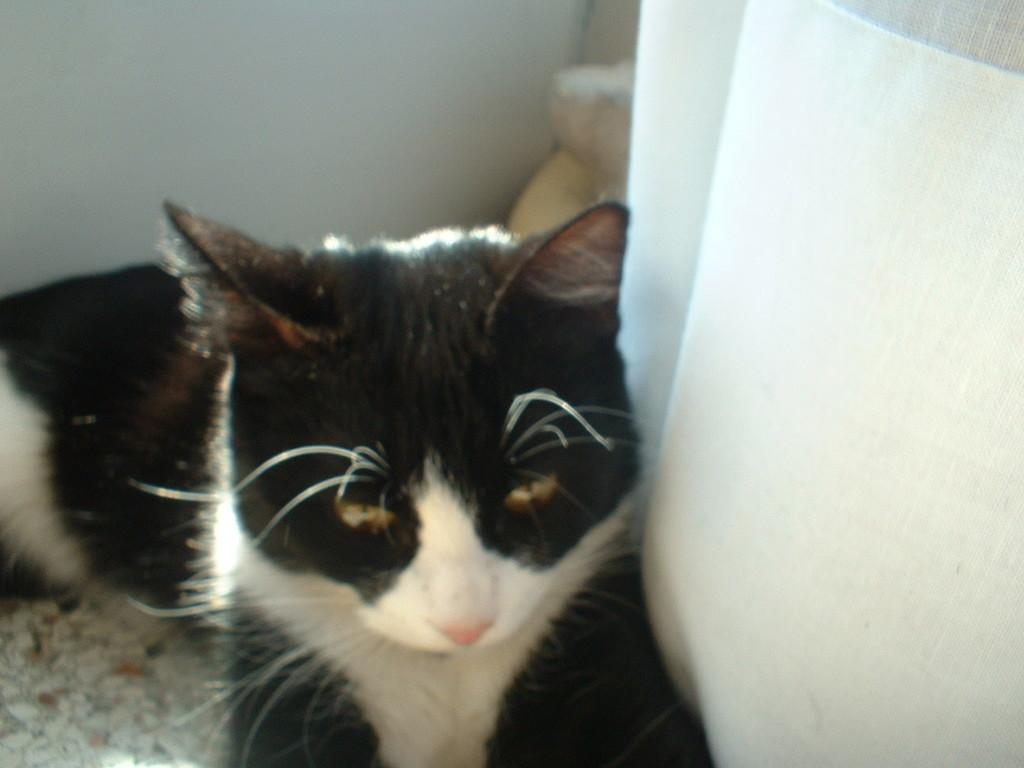What type of animal is in the image? There is a cat in the image. What color is the cat in the image? The cat is in black and white color. Is the cat's son visible in the image? There is no mention of a cat's son in the image, and therefore it cannot be determined if the son is present. 